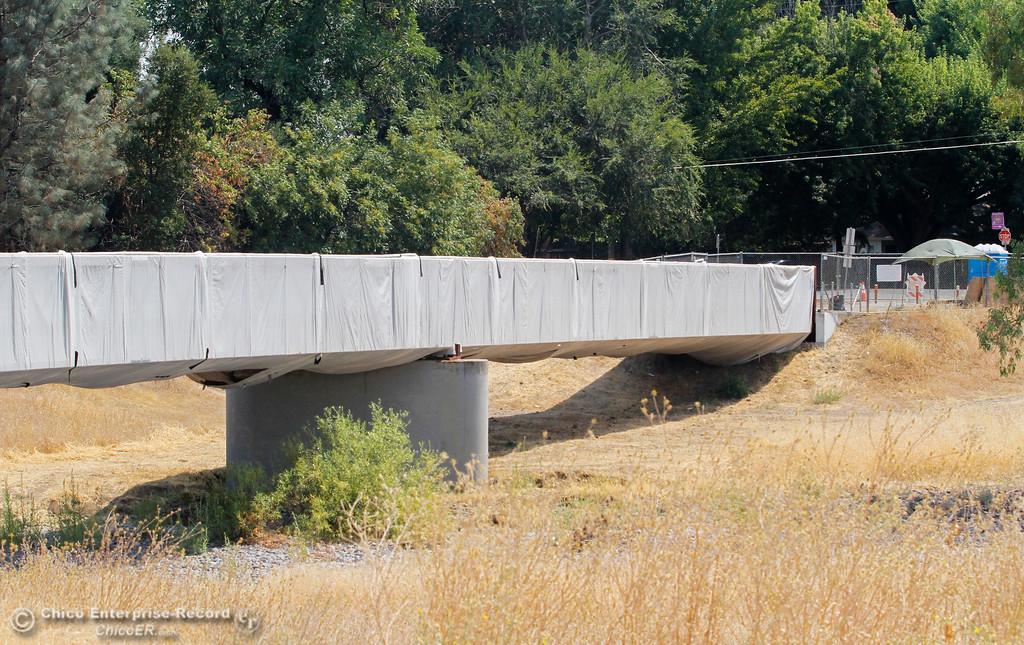What specific environmental considerations might be taken into account during this bridge maintenance? During the bridge maintenance shown, environmental considerations likely include preventing construction debris and materials from entering the nearby natural habitats, which could include streams or wooded areas. Measures such as the tarp might be used to catch paint chips, dust, or other materials. Additionally, the timing of construction might be planned to avoid disrupting local wildlife during sensitive periods, such as breeding seasons. 